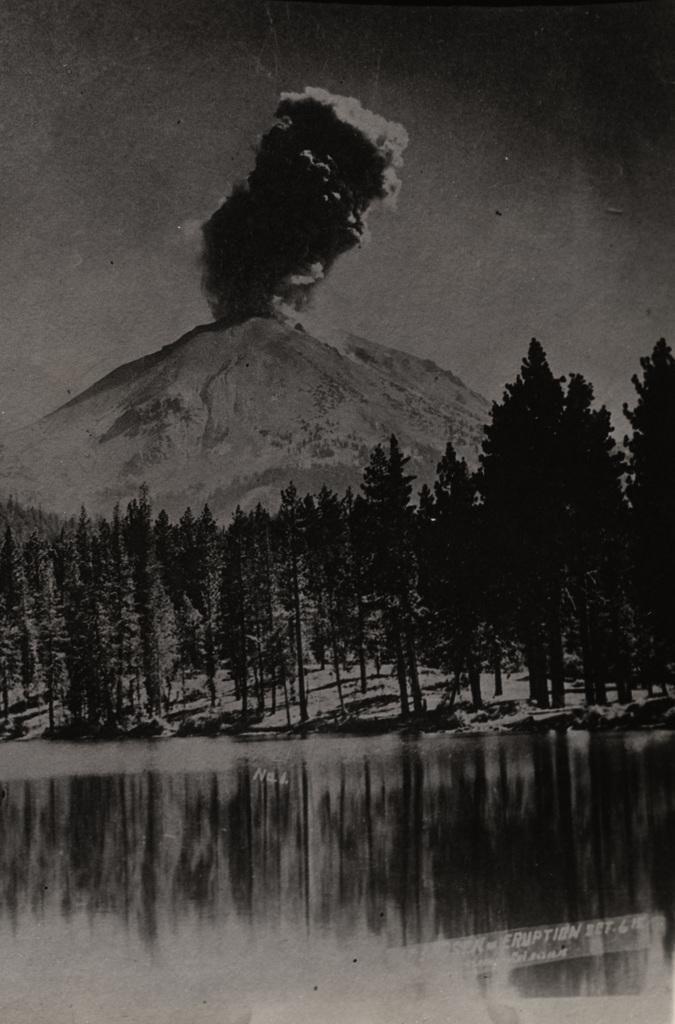How would you summarize this image in a sentence or two? This is a black and white image. At the bottom of the image there is reflection of trees. Behind that there are many trees. Behind the trees there is a volcano hill with smoke. 